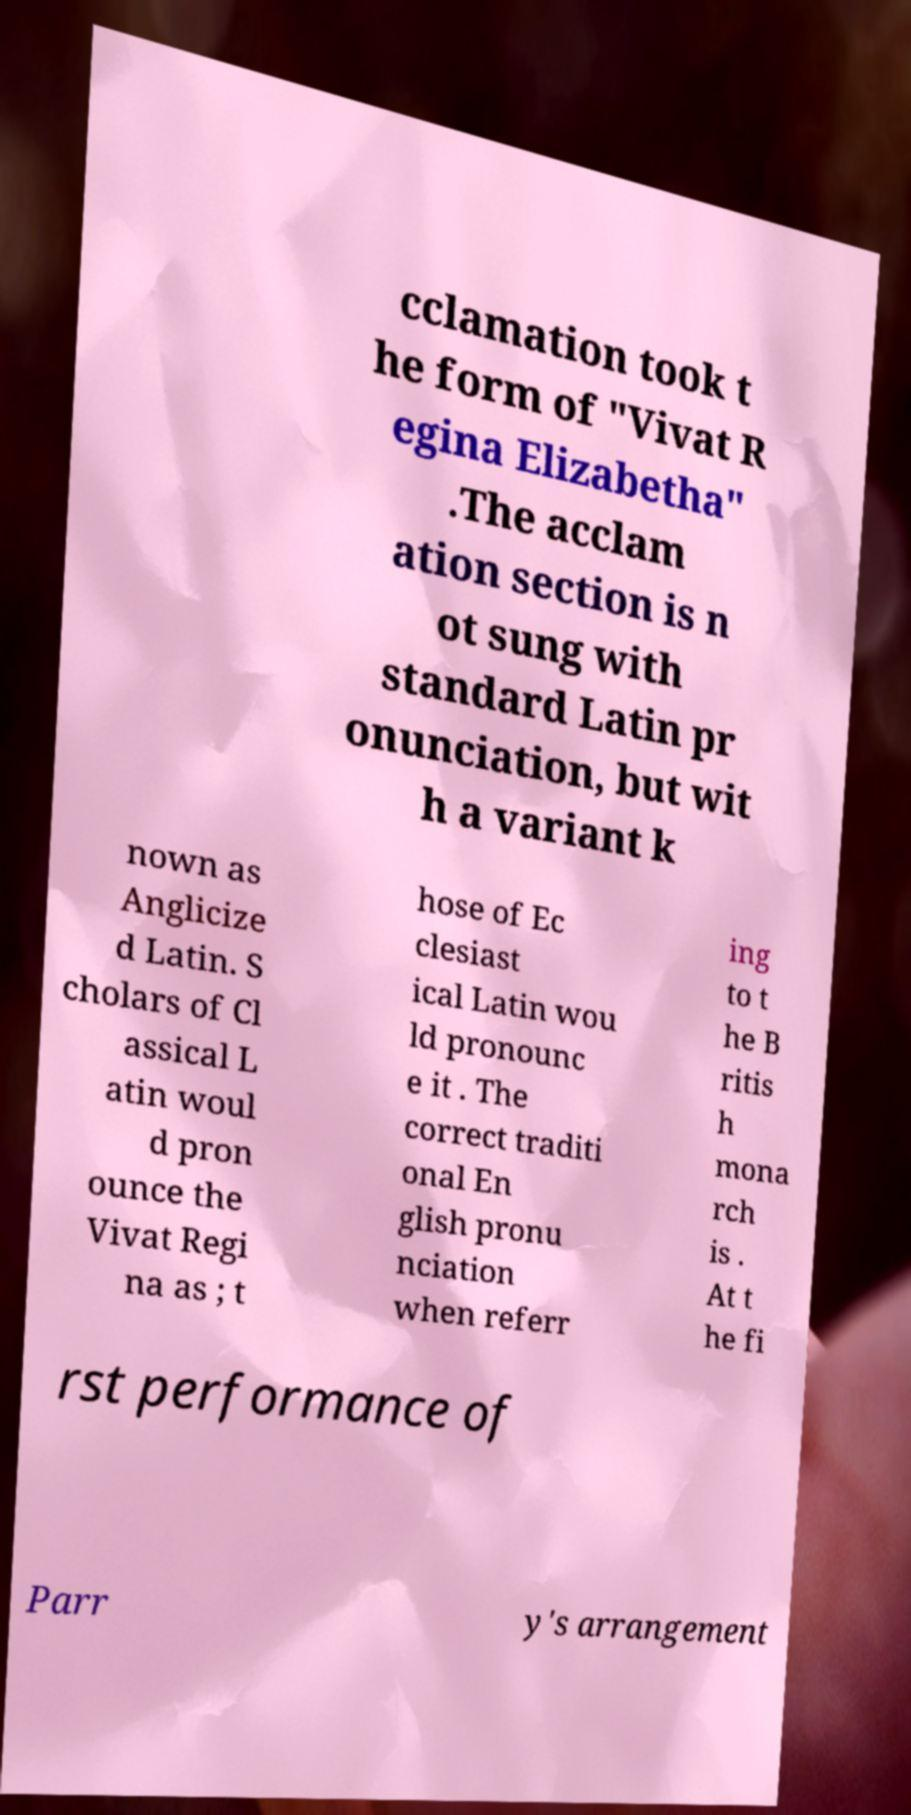Can you accurately transcribe the text from the provided image for me? cclamation took t he form of "Vivat R egina Elizabetha" .The acclam ation section is n ot sung with standard Latin pr onunciation, but wit h a variant k nown as Anglicize d Latin. S cholars of Cl assical L atin woul d pron ounce the Vivat Regi na as ; t hose of Ec clesiast ical Latin wou ld pronounc e it . The correct traditi onal En glish pronu nciation when referr ing to t he B ritis h mona rch is . At t he fi rst performance of Parr y's arrangement 